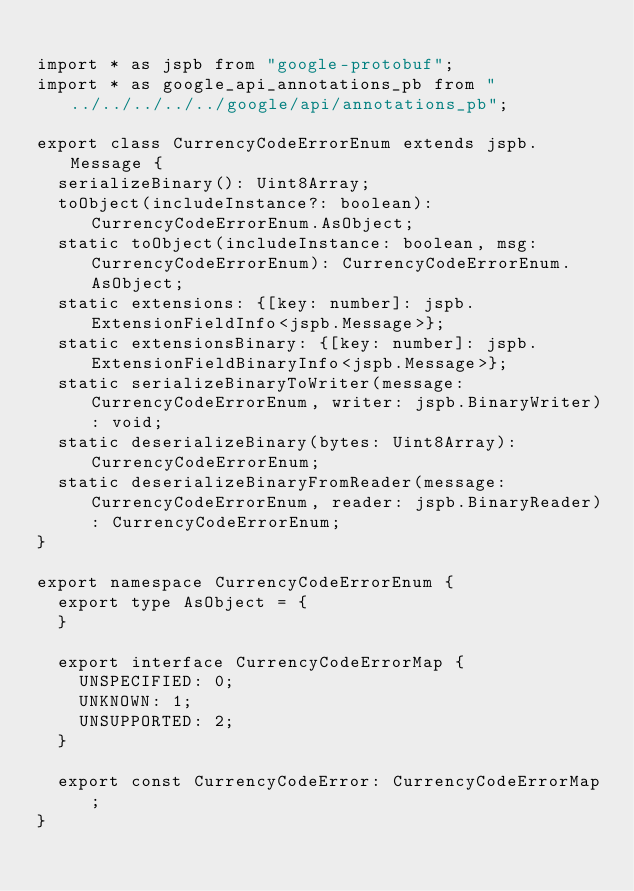<code> <loc_0><loc_0><loc_500><loc_500><_TypeScript_>
import * as jspb from "google-protobuf";
import * as google_api_annotations_pb from "../../../../../google/api/annotations_pb";

export class CurrencyCodeErrorEnum extends jspb.Message {
  serializeBinary(): Uint8Array;
  toObject(includeInstance?: boolean): CurrencyCodeErrorEnum.AsObject;
  static toObject(includeInstance: boolean, msg: CurrencyCodeErrorEnum): CurrencyCodeErrorEnum.AsObject;
  static extensions: {[key: number]: jspb.ExtensionFieldInfo<jspb.Message>};
  static extensionsBinary: {[key: number]: jspb.ExtensionFieldBinaryInfo<jspb.Message>};
  static serializeBinaryToWriter(message: CurrencyCodeErrorEnum, writer: jspb.BinaryWriter): void;
  static deserializeBinary(bytes: Uint8Array): CurrencyCodeErrorEnum;
  static deserializeBinaryFromReader(message: CurrencyCodeErrorEnum, reader: jspb.BinaryReader): CurrencyCodeErrorEnum;
}

export namespace CurrencyCodeErrorEnum {
  export type AsObject = {
  }

  export interface CurrencyCodeErrorMap {
    UNSPECIFIED: 0;
    UNKNOWN: 1;
    UNSUPPORTED: 2;
  }

  export const CurrencyCodeError: CurrencyCodeErrorMap;
}

</code> 